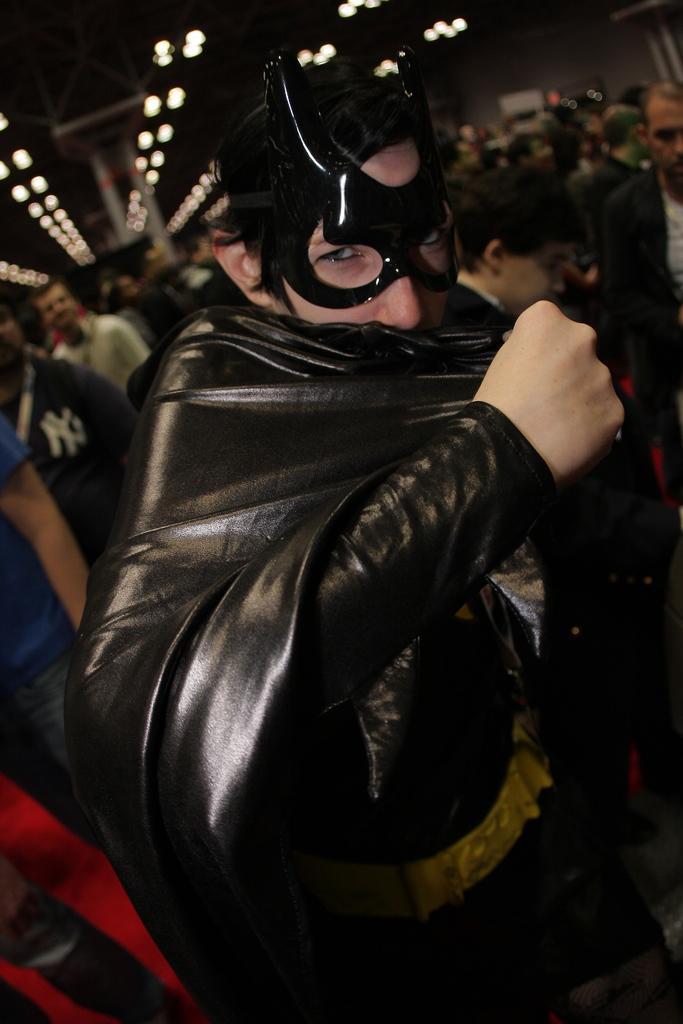In one or two sentences, can you explain what this image depicts? In this image we can see a person wearing batman dress and at the background of the image there are some other persons standing, there are lights. 